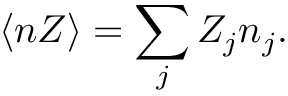Convert formula to latex. <formula><loc_0><loc_0><loc_500><loc_500>\langle n Z \rangle = \sum _ { j } Z _ { j } n _ { j } .</formula> 